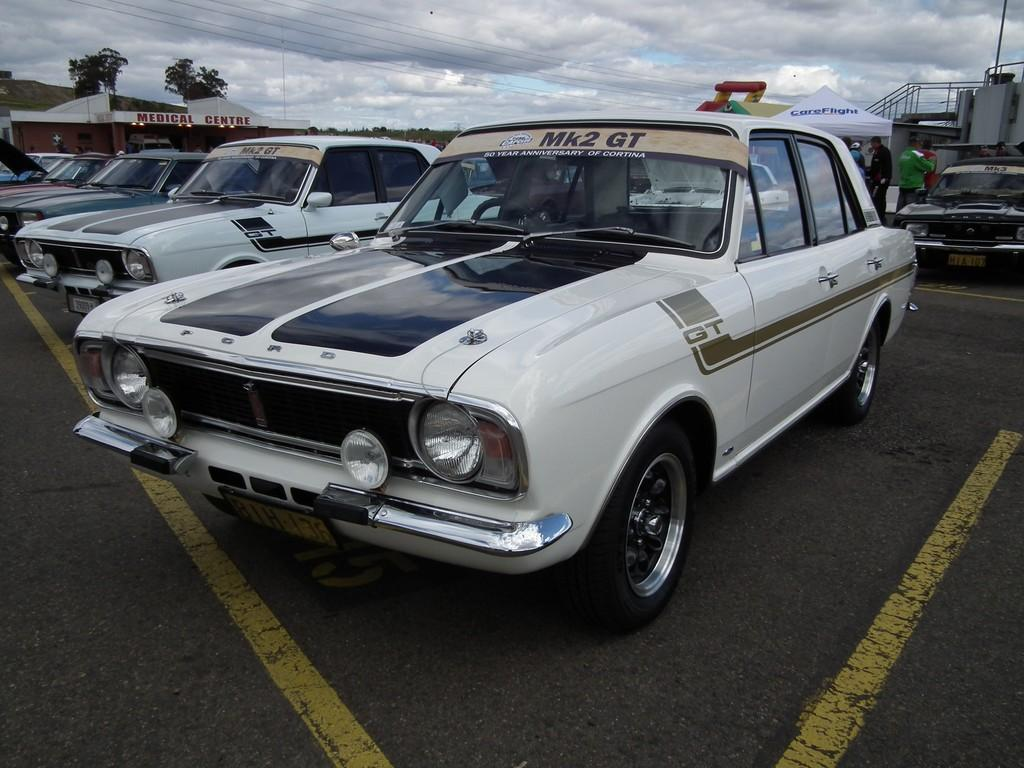What type of vehicles can be seen in the image? There are cars in the image. What structures are present in the image? There are buildings in the image. What type of vegetation is visible in the image? There are trees in the image. What is the tent with text used for in the image? The tent with text is used for displaying information or advertising. What are the people near the tent doing? The people standing near the tent are likely reading the text or engaging with the information displayed on the tent. How would you describe the sky in the image? The sky is blue and cloudy in the image. What type of cheese is being used to build the buildings in the image? There is no cheese present in the image; the buildings are made of traditional construction materials. Can you see any bones in the image? There are no bones visible in the image. 